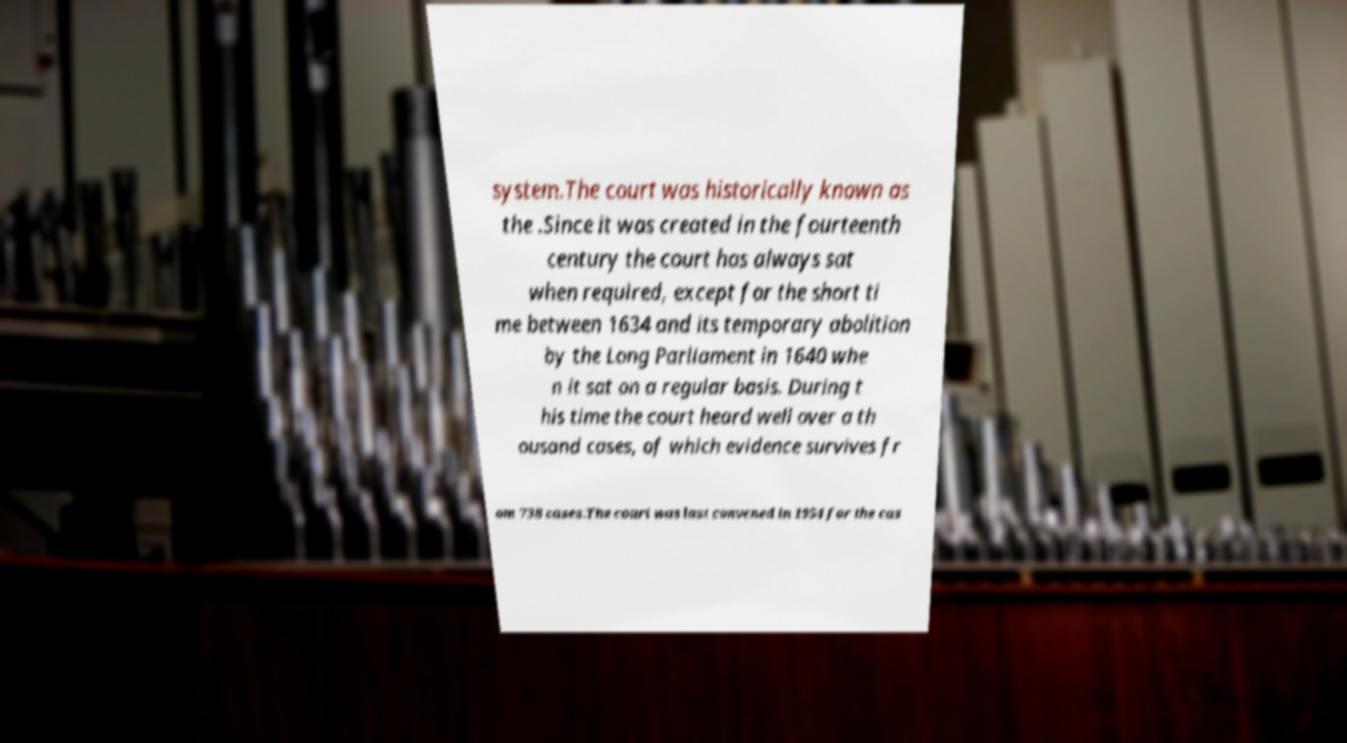Can you accurately transcribe the text from the provided image for me? system.The court was historically known as the .Since it was created in the fourteenth century the court has always sat when required, except for the short ti me between 1634 and its temporary abolition by the Long Parliament in 1640 whe n it sat on a regular basis. During t his time the court heard well over a th ousand cases, of which evidence survives fr om 738 cases.The court was last convened in 1954 for the cas 